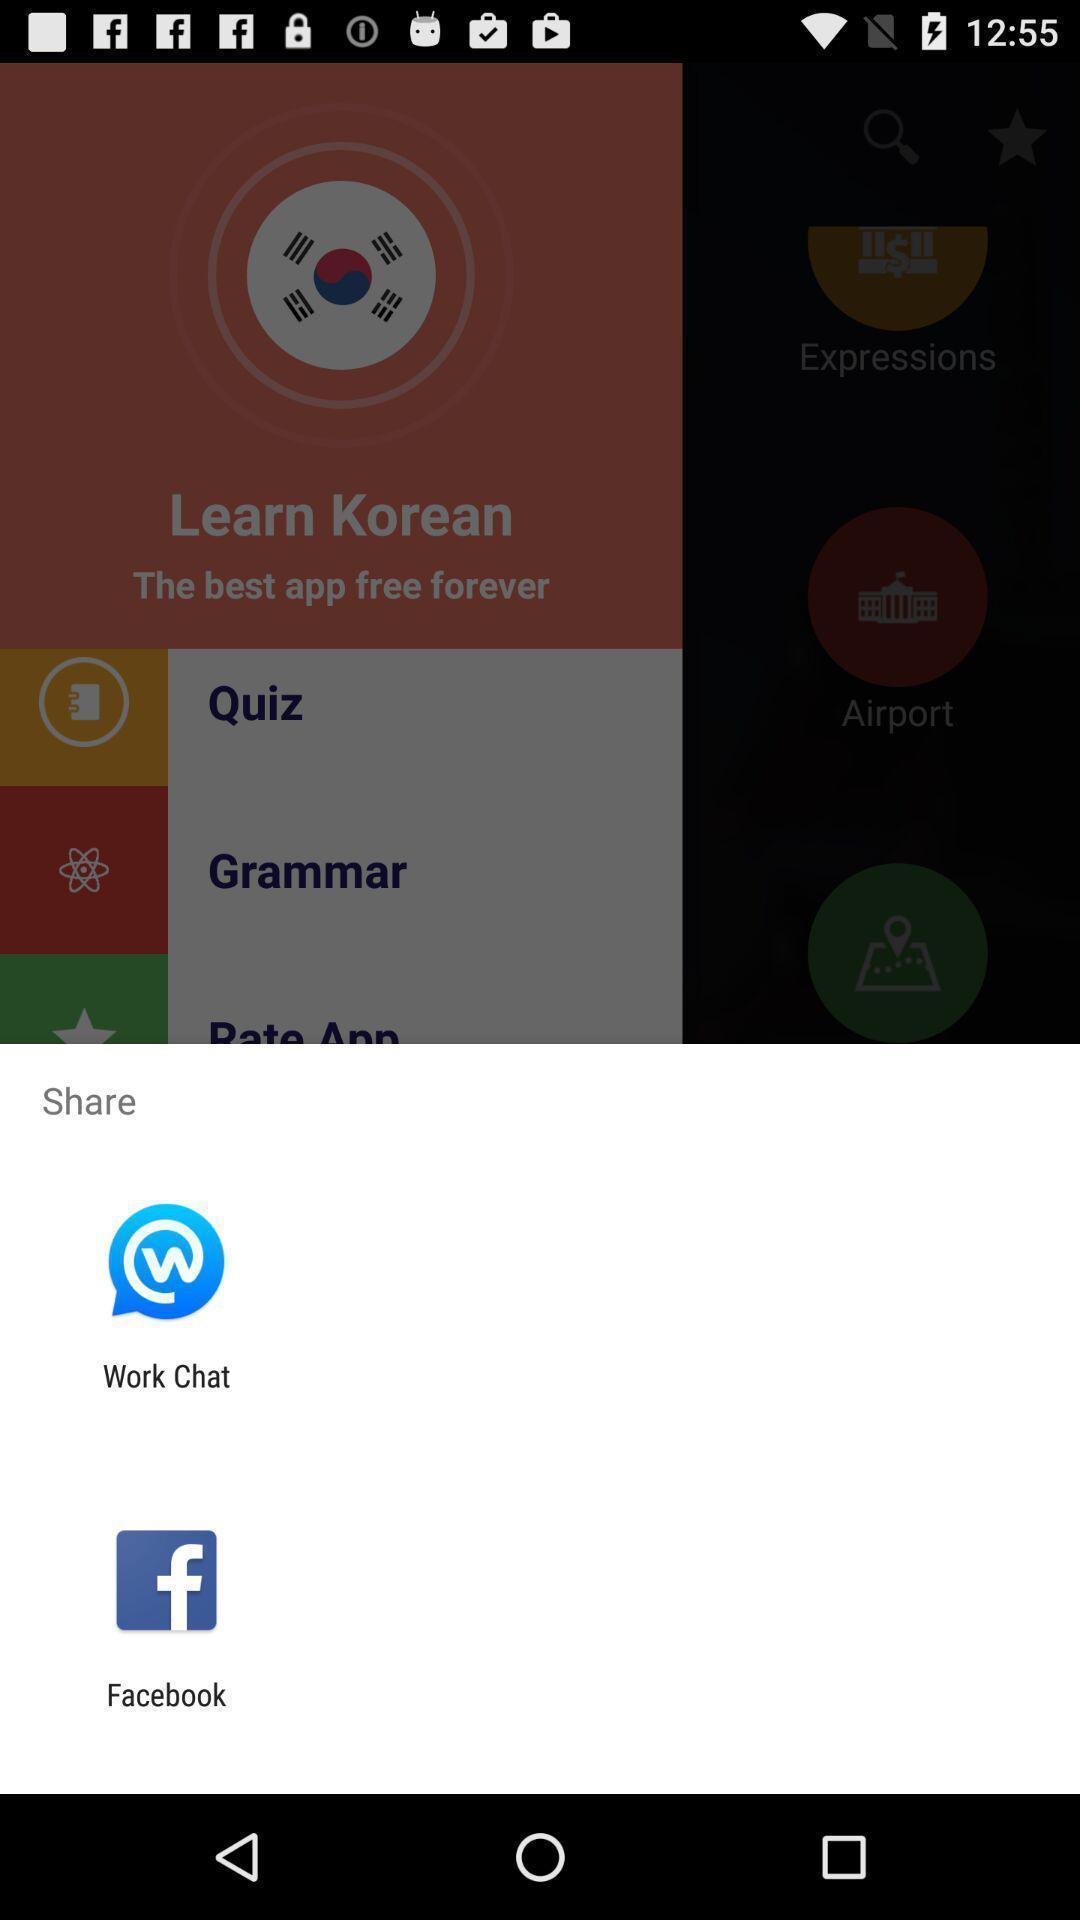Describe the content in this image. Screen displaying sharing options using different social applications. 